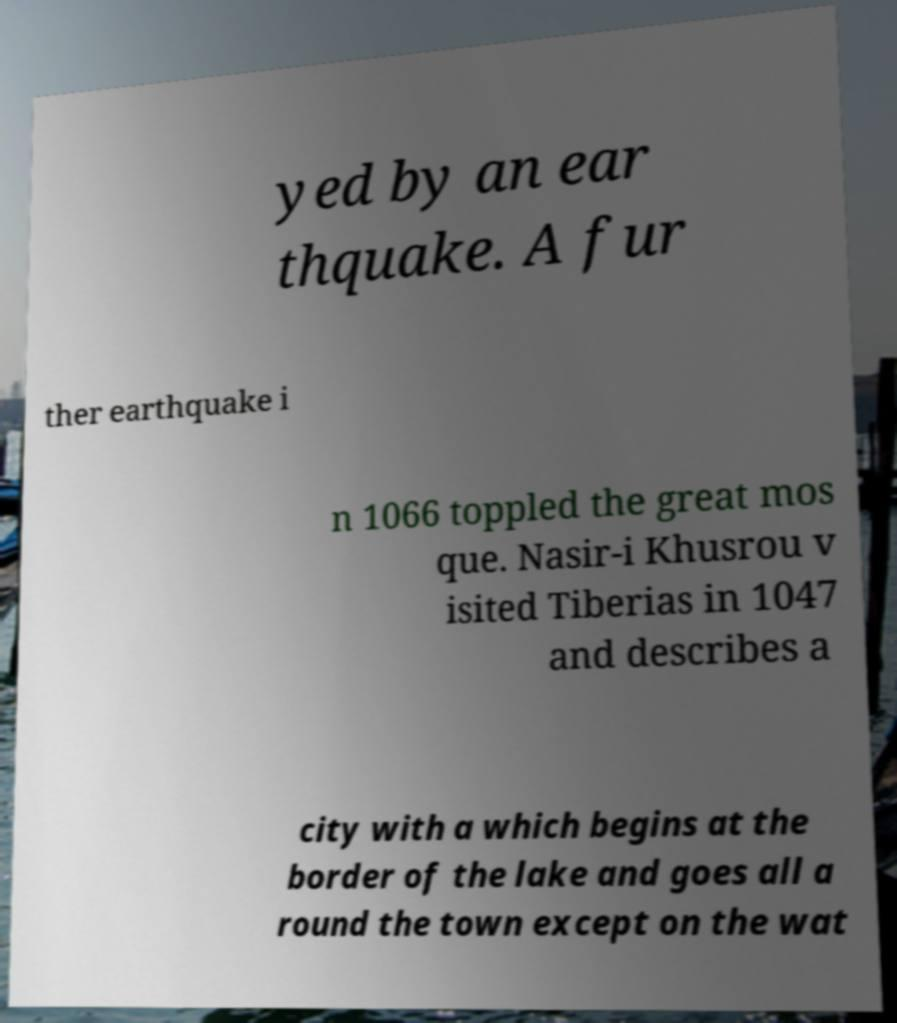Could you assist in decoding the text presented in this image and type it out clearly? yed by an ear thquake. A fur ther earthquake i n 1066 toppled the great mos que. Nasir-i Khusrou v isited Tiberias in 1047 and describes a city with a which begins at the border of the lake and goes all a round the town except on the wat 